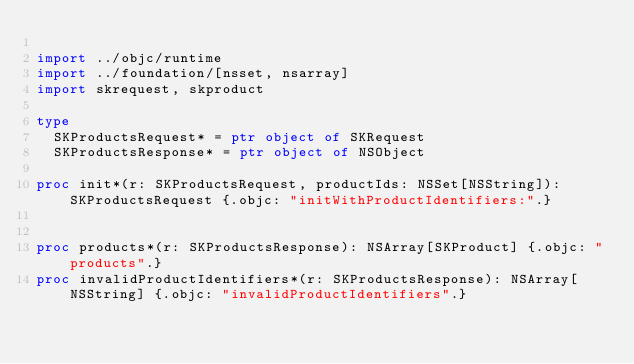<code> <loc_0><loc_0><loc_500><loc_500><_Nim_>
import ../objc/runtime
import ../foundation/[nsset, nsarray]
import skrequest, skproduct

type
  SKProductsRequest* = ptr object of SKRequest
  SKProductsResponse* = ptr object of NSObject

proc init*(r: SKProductsRequest, productIds: NSSet[NSString]): SKProductsRequest {.objc: "initWithProductIdentifiers:".}


proc products*(r: SKProductsResponse): NSArray[SKProduct] {.objc: "products".}
proc invalidProductIdentifiers*(r: SKProductsResponse): NSArray[NSString] {.objc: "invalidProductIdentifiers".}
</code> 